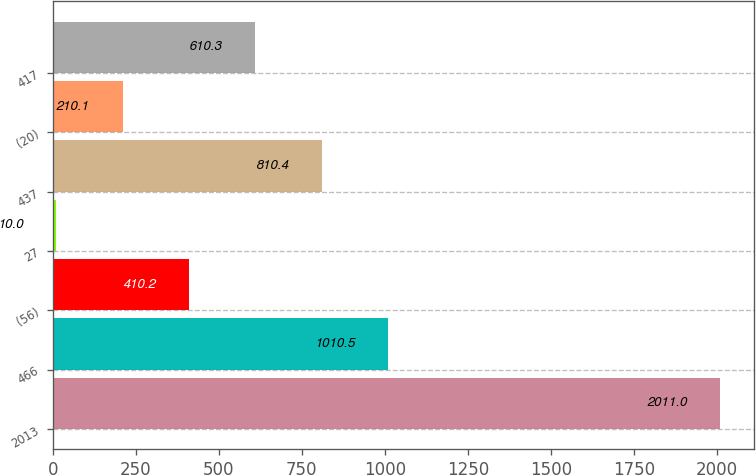Convert chart. <chart><loc_0><loc_0><loc_500><loc_500><bar_chart><fcel>2013<fcel>466<fcel>(56)<fcel>27<fcel>437<fcel>(20)<fcel>417<nl><fcel>2011<fcel>1010.5<fcel>410.2<fcel>10<fcel>810.4<fcel>210.1<fcel>610.3<nl></chart> 